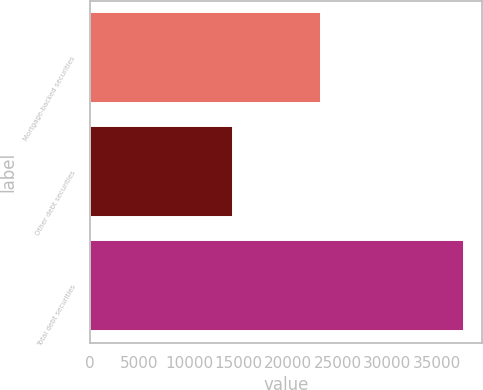Convert chart. <chart><loc_0><loc_0><loc_500><loc_500><bar_chart><fcel>Mortgage-backed securities<fcel>Other debt securities<fcel>Total debt securities<nl><fcel>23344<fcel>14409<fcel>37753<nl></chart> 